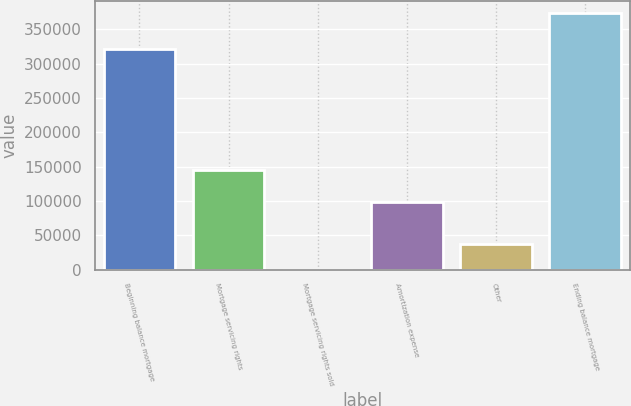<chart> <loc_0><loc_0><loc_500><loc_500><bar_chart><fcel>Beginning balance mortgage<fcel>Mortgage servicing rights<fcel>Mortgage servicing rights sold<fcel>Amortization expense<fcel>Other<fcel>Ending balance mortgage<nl><fcel>320524<fcel>145103<fcel>71<fcel>98559<fcel>37377<fcel>373131<nl></chart> 